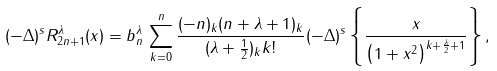Convert formula to latex. <formula><loc_0><loc_0><loc_500><loc_500>& ( - \Delta ) ^ { s } R _ { 2 n + 1 } ^ { \lambda } ( x ) = b _ { n } ^ { \lambda } \, \sum _ { k = 0 } ^ { n } \frac { ( - n ) _ { k } ( n + \lambda + 1 ) _ { k } } { ( \lambda + \frac { 1 } { 2 } ) _ { k } k ! } ( - \Delta ) ^ { s } \left \{ \frac { x } { \left ( 1 + x ^ { 2 } \right ) ^ { k + \frac { \lambda } { 2 } + 1 } } \right \} ,</formula> 